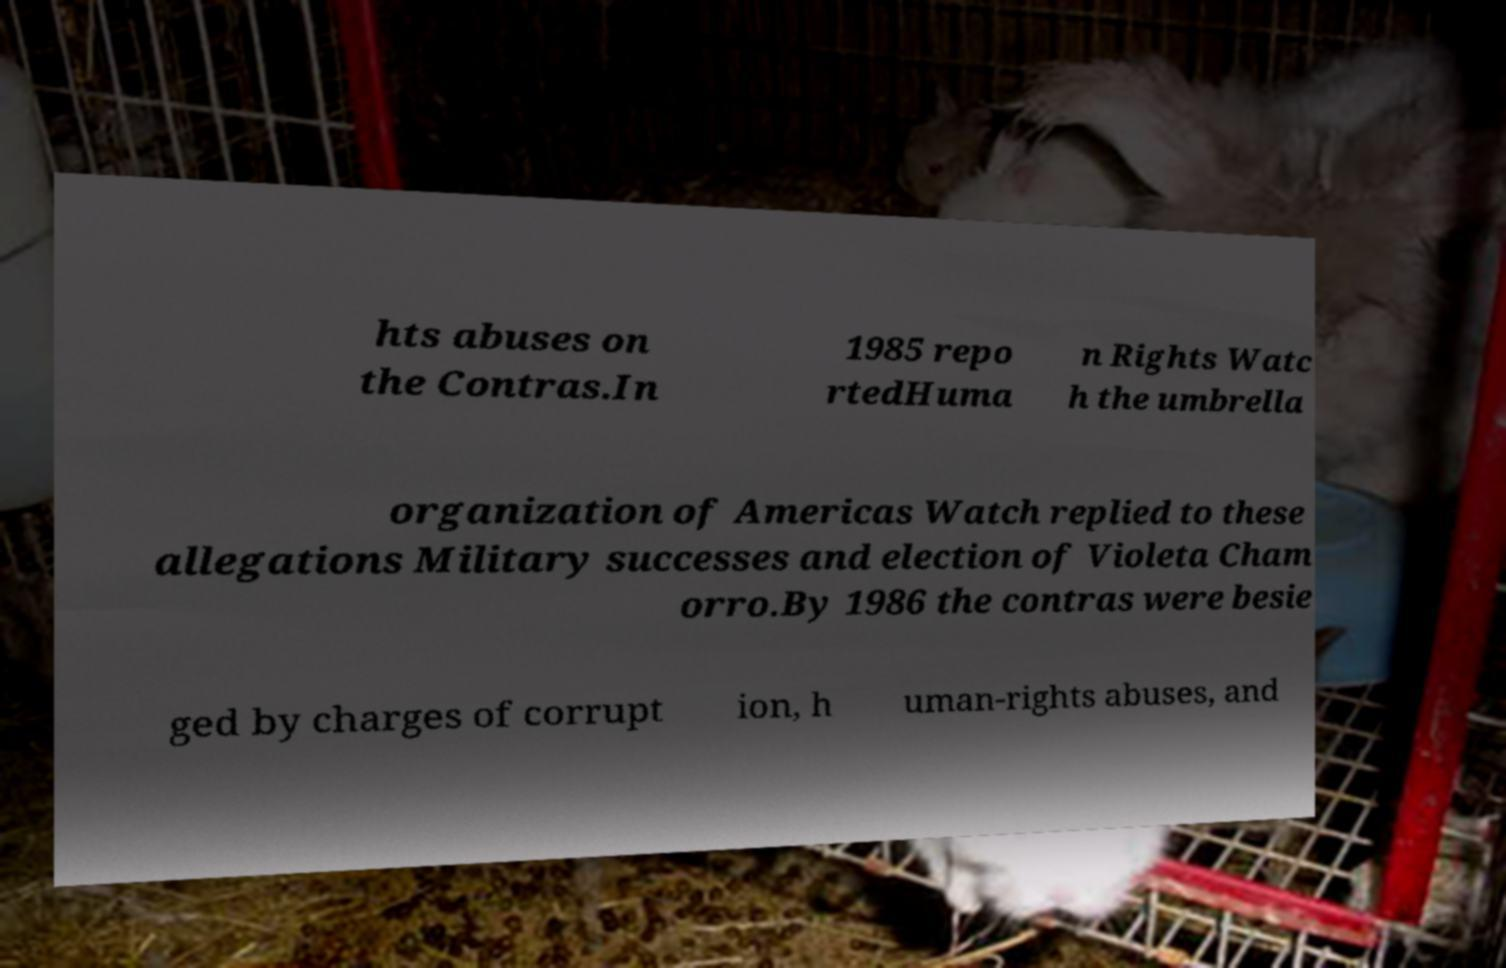Could you extract and type out the text from this image? hts abuses on the Contras.In 1985 repo rtedHuma n Rights Watc h the umbrella organization of Americas Watch replied to these allegations Military successes and election of Violeta Cham orro.By 1986 the contras were besie ged by charges of corrupt ion, h uman-rights abuses, and 